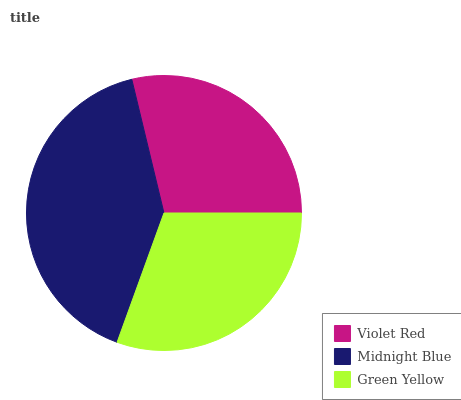Is Violet Red the minimum?
Answer yes or no. Yes. Is Midnight Blue the maximum?
Answer yes or no. Yes. Is Green Yellow the minimum?
Answer yes or no. No. Is Green Yellow the maximum?
Answer yes or no. No. Is Midnight Blue greater than Green Yellow?
Answer yes or no. Yes. Is Green Yellow less than Midnight Blue?
Answer yes or no. Yes. Is Green Yellow greater than Midnight Blue?
Answer yes or no. No. Is Midnight Blue less than Green Yellow?
Answer yes or no. No. Is Green Yellow the high median?
Answer yes or no. Yes. Is Green Yellow the low median?
Answer yes or no. Yes. Is Violet Red the high median?
Answer yes or no. No. Is Midnight Blue the low median?
Answer yes or no. No. 